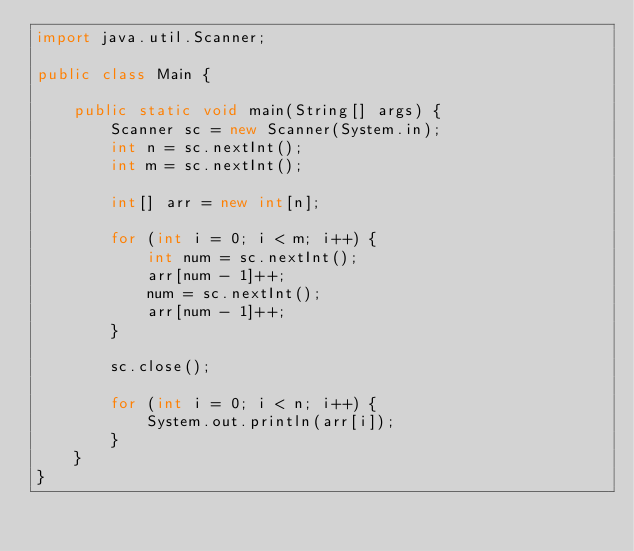Convert code to text. <code><loc_0><loc_0><loc_500><loc_500><_Java_>import java.util.Scanner;

public class Main {

    public static void main(String[] args) {
        Scanner sc = new Scanner(System.in);
        int n = sc.nextInt();
        int m = sc.nextInt();

        int[] arr = new int[n];

        for (int i = 0; i < m; i++) {
            int num = sc.nextInt();
            arr[num - 1]++;
            num = sc.nextInt();
            arr[num - 1]++;
        }

        sc.close();

        for (int i = 0; i < n; i++) {
            System.out.println(arr[i]);
        }
    }
}</code> 